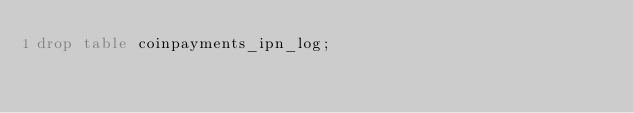Convert code to text. <code><loc_0><loc_0><loc_500><loc_500><_SQL_>drop table coinpayments_ipn_log;
</code> 